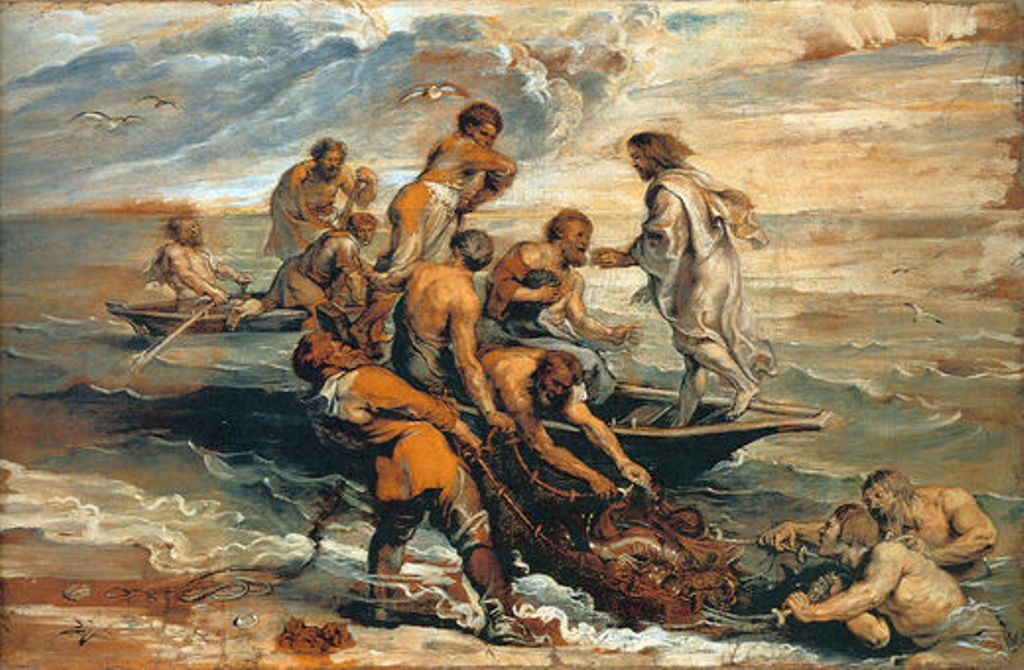Can you describe the emotions portrayed in this painting and their significance? The painting vividly captures a range of human emotions, from desperation and fear to courage and determination. The expressive faces and dynamic poses of the figures enhance the painting's dramatic effect, drawing the viewer into the intensity of the scene. This emotional portrayal is significant as it reflects the Baroque period's emphasis on affecting the viewer, encouraging a deep emotional response to the depicted events which often carry moral or spiritual messages. 